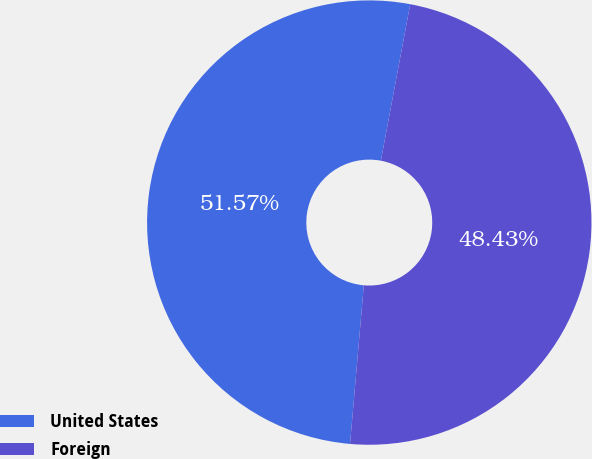Convert chart to OTSL. <chart><loc_0><loc_0><loc_500><loc_500><pie_chart><fcel>United States<fcel>Foreign<nl><fcel>51.57%<fcel>48.43%<nl></chart> 